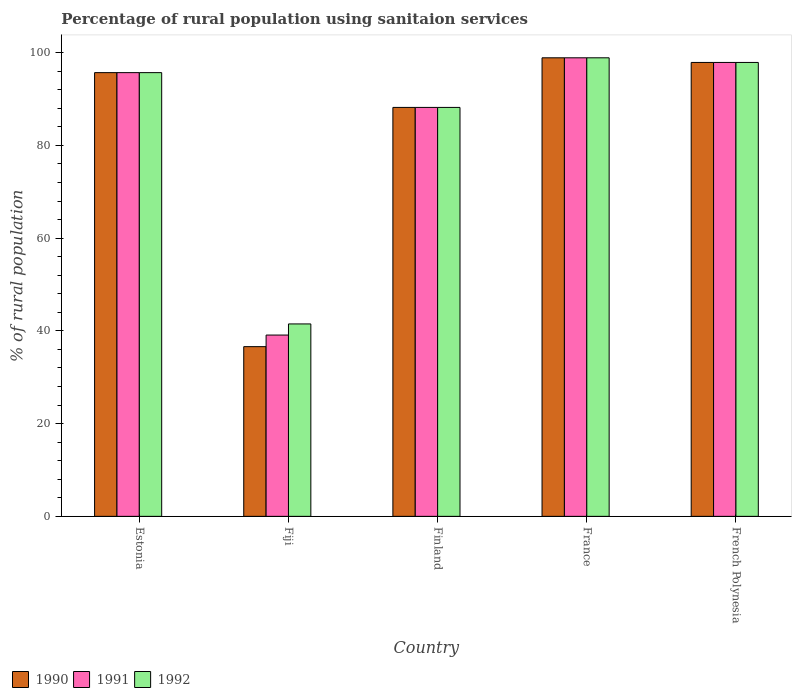How many different coloured bars are there?
Keep it short and to the point. 3. Are the number of bars on each tick of the X-axis equal?
Give a very brief answer. Yes. How many bars are there on the 2nd tick from the left?
Your response must be concise. 3. What is the label of the 2nd group of bars from the left?
Ensure brevity in your answer.  Fiji. What is the percentage of rural population using sanitaion services in 1992 in France?
Your response must be concise. 98.9. Across all countries, what is the maximum percentage of rural population using sanitaion services in 1991?
Your answer should be very brief. 98.9. Across all countries, what is the minimum percentage of rural population using sanitaion services in 1990?
Give a very brief answer. 36.6. In which country was the percentage of rural population using sanitaion services in 1991 maximum?
Keep it short and to the point. France. In which country was the percentage of rural population using sanitaion services in 1992 minimum?
Offer a very short reply. Fiji. What is the total percentage of rural population using sanitaion services in 1991 in the graph?
Offer a very short reply. 419.8. What is the difference between the percentage of rural population using sanitaion services in 1991 in Estonia and that in French Polynesia?
Your response must be concise. -2.2. What is the difference between the percentage of rural population using sanitaion services in 1991 in Fiji and the percentage of rural population using sanitaion services in 1990 in Finland?
Ensure brevity in your answer.  -49.1. What is the average percentage of rural population using sanitaion services in 1991 per country?
Your answer should be very brief. 83.96. What is the difference between the percentage of rural population using sanitaion services of/in 1992 and percentage of rural population using sanitaion services of/in 1990 in Fiji?
Make the answer very short. 4.9. In how many countries, is the percentage of rural population using sanitaion services in 1990 greater than 56 %?
Offer a terse response. 4. What is the ratio of the percentage of rural population using sanitaion services in 1992 in Estonia to that in Finland?
Your answer should be compact. 1.09. What is the difference between the highest and the lowest percentage of rural population using sanitaion services in 1990?
Provide a short and direct response. 62.3. In how many countries, is the percentage of rural population using sanitaion services in 1991 greater than the average percentage of rural population using sanitaion services in 1991 taken over all countries?
Give a very brief answer. 4. Is the sum of the percentage of rural population using sanitaion services in 1991 in Estonia and Finland greater than the maximum percentage of rural population using sanitaion services in 1990 across all countries?
Offer a very short reply. Yes. What does the 3rd bar from the left in Estonia represents?
Keep it short and to the point. 1992. Are the values on the major ticks of Y-axis written in scientific E-notation?
Make the answer very short. No. Does the graph contain any zero values?
Your answer should be very brief. No. Does the graph contain grids?
Your response must be concise. No. How many legend labels are there?
Give a very brief answer. 3. How are the legend labels stacked?
Ensure brevity in your answer.  Horizontal. What is the title of the graph?
Your answer should be compact. Percentage of rural population using sanitaion services. What is the label or title of the X-axis?
Your answer should be very brief. Country. What is the label or title of the Y-axis?
Provide a succinct answer. % of rural population. What is the % of rural population of 1990 in Estonia?
Your answer should be very brief. 95.7. What is the % of rural population in 1991 in Estonia?
Ensure brevity in your answer.  95.7. What is the % of rural population in 1992 in Estonia?
Your response must be concise. 95.7. What is the % of rural population of 1990 in Fiji?
Your answer should be compact. 36.6. What is the % of rural population in 1991 in Fiji?
Provide a short and direct response. 39.1. What is the % of rural population of 1992 in Fiji?
Your answer should be very brief. 41.5. What is the % of rural population of 1990 in Finland?
Provide a short and direct response. 88.2. What is the % of rural population of 1991 in Finland?
Provide a succinct answer. 88.2. What is the % of rural population in 1992 in Finland?
Give a very brief answer. 88.2. What is the % of rural population in 1990 in France?
Ensure brevity in your answer.  98.9. What is the % of rural population in 1991 in France?
Offer a terse response. 98.9. What is the % of rural population in 1992 in France?
Your response must be concise. 98.9. What is the % of rural population of 1990 in French Polynesia?
Ensure brevity in your answer.  97.9. What is the % of rural population of 1991 in French Polynesia?
Offer a very short reply. 97.9. What is the % of rural population in 1992 in French Polynesia?
Provide a succinct answer. 97.9. Across all countries, what is the maximum % of rural population of 1990?
Ensure brevity in your answer.  98.9. Across all countries, what is the maximum % of rural population of 1991?
Your answer should be very brief. 98.9. Across all countries, what is the maximum % of rural population of 1992?
Provide a succinct answer. 98.9. Across all countries, what is the minimum % of rural population in 1990?
Provide a succinct answer. 36.6. Across all countries, what is the minimum % of rural population in 1991?
Offer a very short reply. 39.1. Across all countries, what is the minimum % of rural population in 1992?
Your answer should be very brief. 41.5. What is the total % of rural population of 1990 in the graph?
Your response must be concise. 417.3. What is the total % of rural population in 1991 in the graph?
Offer a terse response. 419.8. What is the total % of rural population of 1992 in the graph?
Give a very brief answer. 422.2. What is the difference between the % of rural population in 1990 in Estonia and that in Fiji?
Keep it short and to the point. 59.1. What is the difference between the % of rural population in 1991 in Estonia and that in Fiji?
Offer a very short reply. 56.6. What is the difference between the % of rural population of 1992 in Estonia and that in Fiji?
Your response must be concise. 54.2. What is the difference between the % of rural population in 1990 in Estonia and that in Finland?
Your response must be concise. 7.5. What is the difference between the % of rural population of 1992 in Estonia and that in Finland?
Provide a short and direct response. 7.5. What is the difference between the % of rural population in 1992 in Estonia and that in France?
Keep it short and to the point. -3.2. What is the difference between the % of rural population in 1991 in Estonia and that in French Polynesia?
Your answer should be very brief. -2.2. What is the difference between the % of rural population of 1992 in Estonia and that in French Polynesia?
Your response must be concise. -2.2. What is the difference between the % of rural population in 1990 in Fiji and that in Finland?
Ensure brevity in your answer.  -51.6. What is the difference between the % of rural population in 1991 in Fiji and that in Finland?
Provide a short and direct response. -49.1. What is the difference between the % of rural population in 1992 in Fiji and that in Finland?
Keep it short and to the point. -46.7. What is the difference between the % of rural population in 1990 in Fiji and that in France?
Ensure brevity in your answer.  -62.3. What is the difference between the % of rural population of 1991 in Fiji and that in France?
Provide a short and direct response. -59.8. What is the difference between the % of rural population of 1992 in Fiji and that in France?
Ensure brevity in your answer.  -57.4. What is the difference between the % of rural population of 1990 in Fiji and that in French Polynesia?
Give a very brief answer. -61.3. What is the difference between the % of rural population of 1991 in Fiji and that in French Polynesia?
Provide a succinct answer. -58.8. What is the difference between the % of rural population of 1992 in Fiji and that in French Polynesia?
Your answer should be compact. -56.4. What is the difference between the % of rural population in 1990 in Finland and that in French Polynesia?
Ensure brevity in your answer.  -9.7. What is the difference between the % of rural population in 1991 in Finland and that in French Polynesia?
Keep it short and to the point. -9.7. What is the difference between the % of rural population in 1992 in Finland and that in French Polynesia?
Your answer should be compact. -9.7. What is the difference between the % of rural population of 1992 in France and that in French Polynesia?
Provide a succinct answer. 1. What is the difference between the % of rural population in 1990 in Estonia and the % of rural population in 1991 in Fiji?
Your answer should be very brief. 56.6. What is the difference between the % of rural population in 1990 in Estonia and the % of rural population in 1992 in Fiji?
Your answer should be very brief. 54.2. What is the difference between the % of rural population in 1991 in Estonia and the % of rural population in 1992 in Fiji?
Make the answer very short. 54.2. What is the difference between the % of rural population in 1990 in Estonia and the % of rural population in 1991 in France?
Ensure brevity in your answer.  -3.2. What is the difference between the % of rural population of 1990 in Estonia and the % of rural population of 1992 in France?
Keep it short and to the point. -3.2. What is the difference between the % of rural population of 1990 in Estonia and the % of rural population of 1992 in French Polynesia?
Your answer should be compact. -2.2. What is the difference between the % of rural population of 1990 in Fiji and the % of rural population of 1991 in Finland?
Your answer should be compact. -51.6. What is the difference between the % of rural population of 1990 in Fiji and the % of rural population of 1992 in Finland?
Make the answer very short. -51.6. What is the difference between the % of rural population of 1991 in Fiji and the % of rural population of 1992 in Finland?
Your answer should be compact. -49.1. What is the difference between the % of rural population in 1990 in Fiji and the % of rural population in 1991 in France?
Make the answer very short. -62.3. What is the difference between the % of rural population of 1990 in Fiji and the % of rural population of 1992 in France?
Keep it short and to the point. -62.3. What is the difference between the % of rural population of 1991 in Fiji and the % of rural population of 1992 in France?
Keep it short and to the point. -59.8. What is the difference between the % of rural population in 1990 in Fiji and the % of rural population in 1991 in French Polynesia?
Your answer should be compact. -61.3. What is the difference between the % of rural population of 1990 in Fiji and the % of rural population of 1992 in French Polynesia?
Provide a short and direct response. -61.3. What is the difference between the % of rural population in 1991 in Fiji and the % of rural population in 1992 in French Polynesia?
Keep it short and to the point. -58.8. What is the difference between the % of rural population in 1990 in Finland and the % of rural population in 1991 in France?
Make the answer very short. -10.7. What is the difference between the % of rural population of 1990 in France and the % of rural population of 1992 in French Polynesia?
Your response must be concise. 1. What is the average % of rural population in 1990 per country?
Provide a succinct answer. 83.46. What is the average % of rural population in 1991 per country?
Your answer should be very brief. 83.96. What is the average % of rural population of 1992 per country?
Offer a terse response. 84.44. What is the difference between the % of rural population of 1990 and % of rural population of 1991 in Estonia?
Ensure brevity in your answer.  0. What is the difference between the % of rural population of 1990 and % of rural population of 1991 in Fiji?
Keep it short and to the point. -2.5. What is the difference between the % of rural population of 1990 and % of rural population of 1991 in Finland?
Keep it short and to the point. 0. What is the difference between the % of rural population in 1990 and % of rural population in 1992 in France?
Your response must be concise. 0. What is the difference between the % of rural population of 1991 and % of rural population of 1992 in France?
Your answer should be very brief. 0. What is the difference between the % of rural population in 1990 and % of rural population in 1992 in French Polynesia?
Give a very brief answer. 0. What is the difference between the % of rural population of 1991 and % of rural population of 1992 in French Polynesia?
Ensure brevity in your answer.  0. What is the ratio of the % of rural population of 1990 in Estonia to that in Fiji?
Your answer should be compact. 2.61. What is the ratio of the % of rural population of 1991 in Estonia to that in Fiji?
Provide a succinct answer. 2.45. What is the ratio of the % of rural population in 1992 in Estonia to that in Fiji?
Provide a succinct answer. 2.31. What is the ratio of the % of rural population in 1990 in Estonia to that in Finland?
Your response must be concise. 1.08. What is the ratio of the % of rural population of 1991 in Estonia to that in Finland?
Give a very brief answer. 1.08. What is the ratio of the % of rural population in 1992 in Estonia to that in Finland?
Keep it short and to the point. 1.08. What is the ratio of the % of rural population of 1990 in Estonia to that in France?
Give a very brief answer. 0.97. What is the ratio of the % of rural population in 1991 in Estonia to that in France?
Your answer should be very brief. 0.97. What is the ratio of the % of rural population in 1992 in Estonia to that in France?
Your response must be concise. 0.97. What is the ratio of the % of rural population in 1990 in Estonia to that in French Polynesia?
Your answer should be very brief. 0.98. What is the ratio of the % of rural population of 1991 in Estonia to that in French Polynesia?
Provide a short and direct response. 0.98. What is the ratio of the % of rural population in 1992 in Estonia to that in French Polynesia?
Make the answer very short. 0.98. What is the ratio of the % of rural population of 1990 in Fiji to that in Finland?
Keep it short and to the point. 0.41. What is the ratio of the % of rural population of 1991 in Fiji to that in Finland?
Your response must be concise. 0.44. What is the ratio of the % of rural population in 1992 in Fiji to that in Finland?
Give a very brief answer. 0.47. What is the ratio of the % of rural population in 1990 in Fiji to that in France?
Your response must be concise. 0.37. What is the ratio of the % of rural population in 1991 in Fiji to that in France?
Keep it short and to the point. 0.4. What is the ratio of the % of rural population in 1992 in Fiji to that in France?
Offer a terse response. 0.42. What is the ratio of the % of rural population in 1990 in Fiji to that in French Polynesia?
Provide a succinct answer. 0.37. What is the ratio of the % of rural population of 1991 in Fiji to that in French Polynesia?
Keep it short and to the point. 0.4. What is the ratio of the % of rural population in 1992 in Fiji to that in French Polynesia?
Keep it short and to the point. 0.42. What is the ratio of the % of rural population in 1990 in Finland to that in France?
Make the answer very short. 0.89. What is the ratio of the % of rural population of 1991 in Finland to that in France?
Make the answer very short. 0.89. What is the ratio of the % of rural population of 1992 in Finland to that in France?
Your response must be concise. 0.89. What is the ratio of the % of rural population of 1990 in Finland to that in French Polynesia?
Offer a terse response. 0.9. What is the ratio of the % of rural population in 1991 in Finland to that in French Polynesia?
Ensure brevity in your answer.  0.9. What is the ratio of the % of rural population of 1992 in Finland to that in French Polynesia?
Give a very brief answer. 0.9. What is the ratio of the % of rural population in 1990 in France to that in French Polynesia?
Your answer should be very brief. 1.01. What is the ratio of the % of rural population of 1991 in France to that in French Polynesia?
Your answer should be very brief. 1.01. What is the ratio of the % of rural population of 1992 in France to that in French Polynesia?
Provide a short and direct response. 1.01. What is the difference between the highest and the second highest % of rural population of 1990?
Ensure brevity in your answer.  1. What is the difference between the highest and the second highest % of rural population in 1992?
Your answer should be very brief. 1. What is the difference between the highest and the lowest % of rural population in 1990?
Provide a succinct answer. 62.3. What is the difference between the highest and the lowest % of rural population of 1991?
Your response must be concise. 59.8. What is the difference between the highest and the lowest % of rural population in 1992?
Your response must be concise. 57.4. 